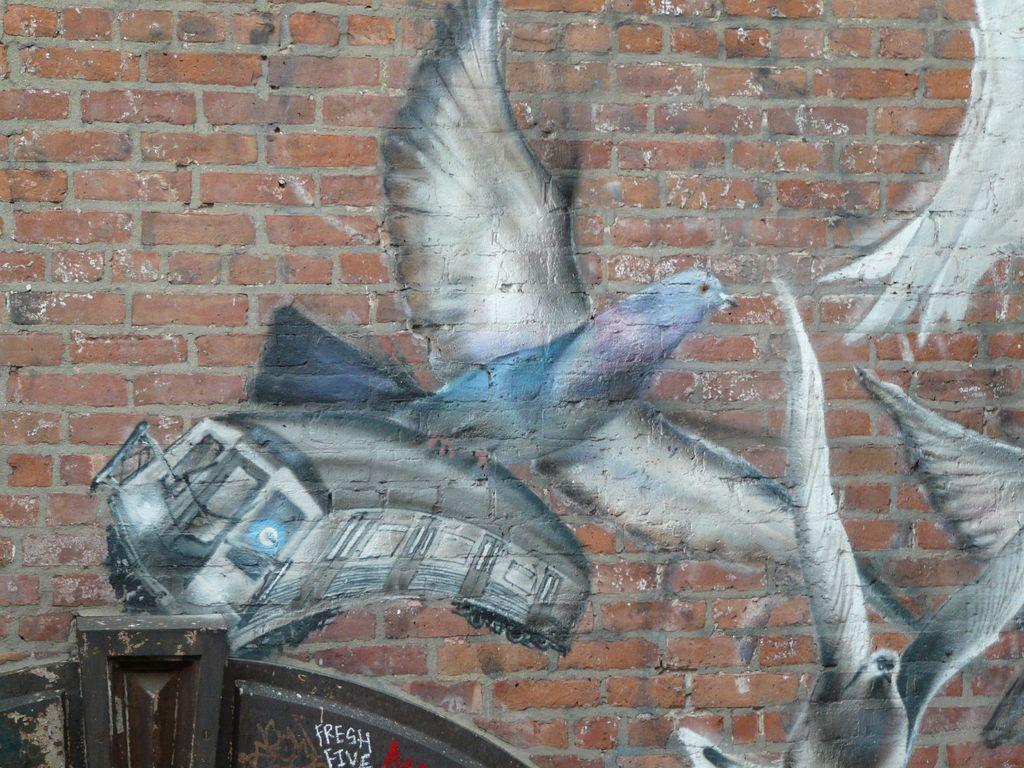In one or two sentences, can you explain what this image depicts? In this image there is a wall with painting of birds and bus. 